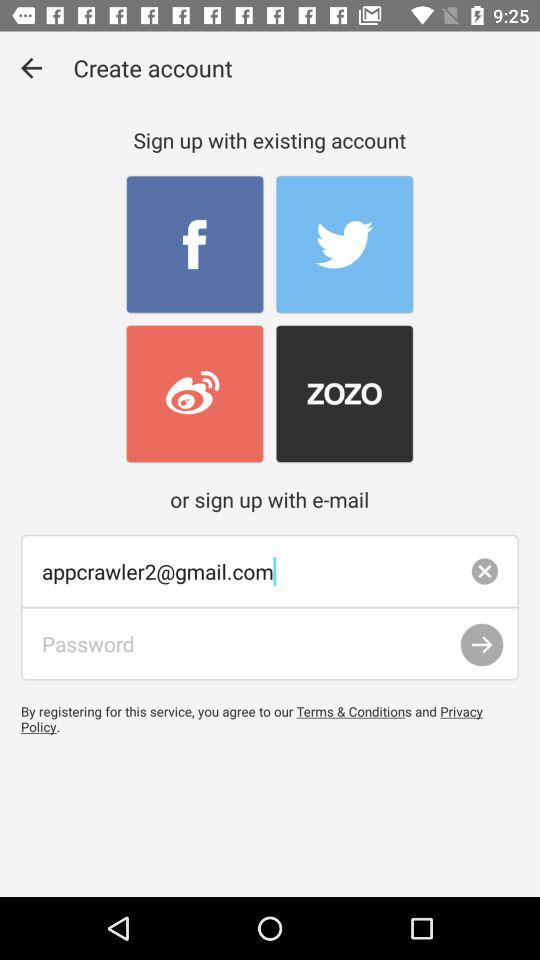How many text inputs are there for creating an account?
Answer the question using a single word or phrase. 2 